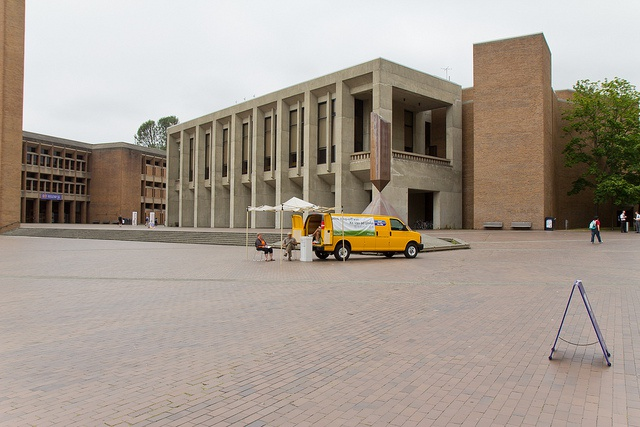Describe the objects in this image and their specific colors. I can see truck in tan, orange, black, lightgray, and darkgray tones, people in tan, black, gray, and darkgray tones, people in tan, gray, maroon, and darkgray tones, people in tan, black, gray, maroon, and brown tones, and bench in tan and gray tones in this image. 